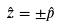<formula> <loc_0><loc_0><loc_500><loc_500>\hat { z } = \pm \hat { p }</formula> 